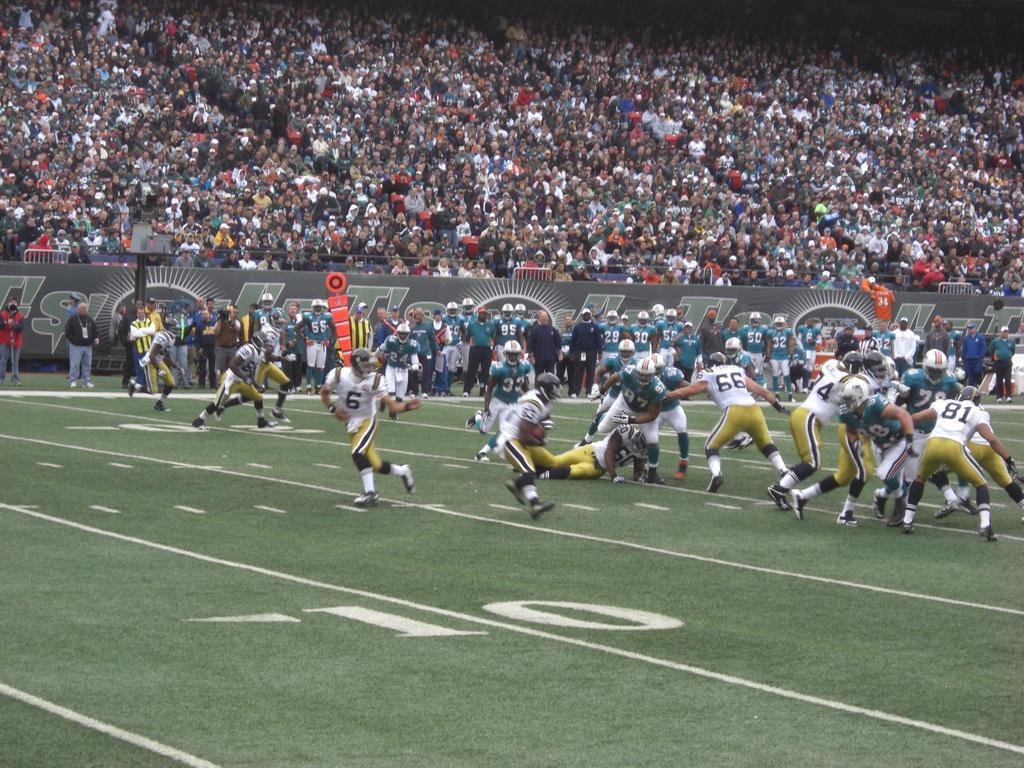How would you summarize this image in a sentence or two? In this image there are persons playing in the center. In the background there are persons standing and sitting and there is a board with some text written on it. In the front there is some number written on the ground. 